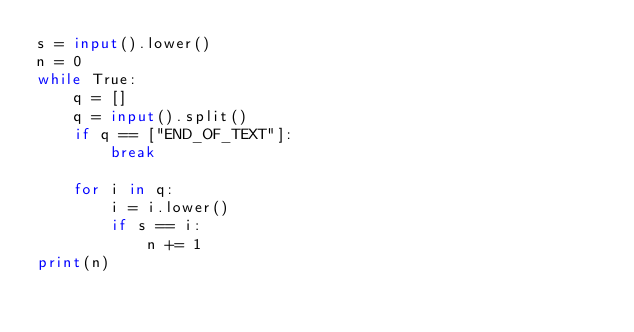Convert code to text. <code><loc_0><loc_0><loc_500><loc_500><_Python_>s = input().lower()
n = 0
while True:
    q = []
    q = input().split()
    if q == ["END_OF_TEXT"]:
        break

    for i in q:
        i = i.lower()
        if s == i:
            n += 1
print(n)</code> 